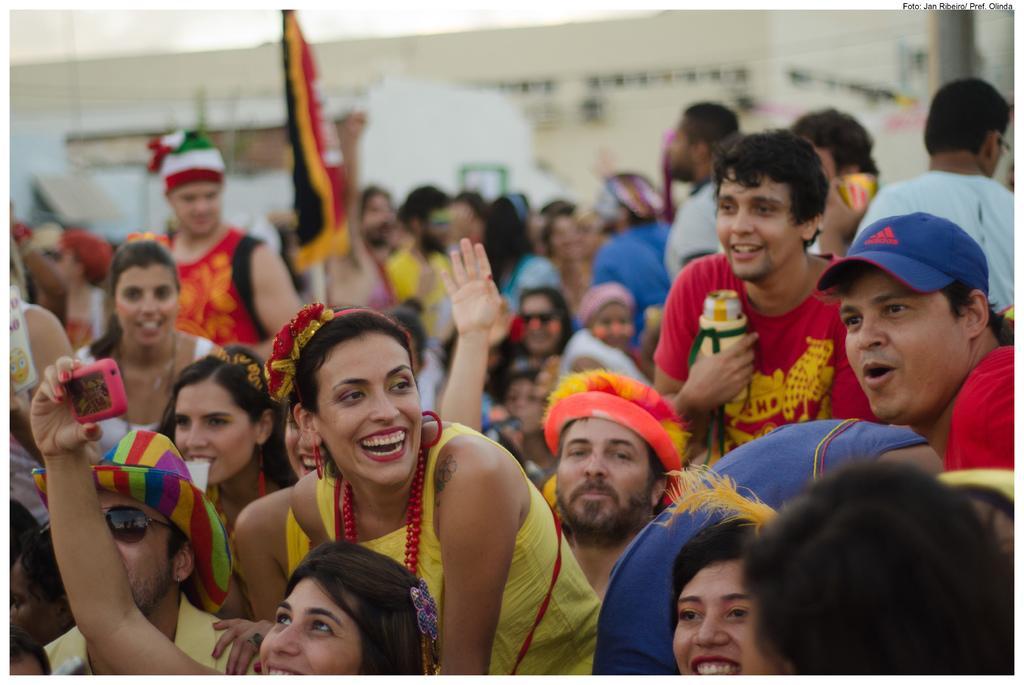In one or two sentences, can you explain what this image depicts? In this image we can see a group of people and few of them holding objects, there is a flag, blurred background. 